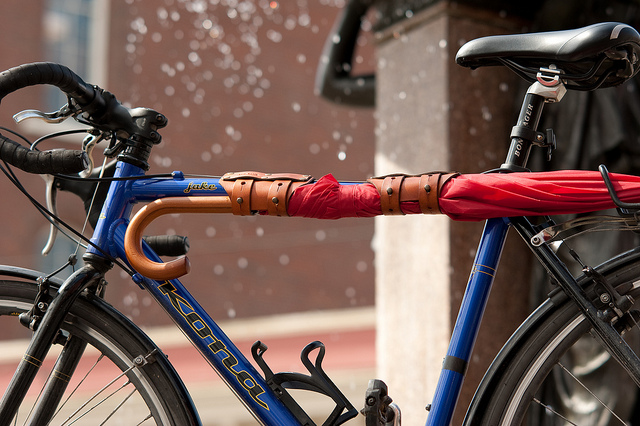Identify and read out the text in this image. JUKE kona AGER BON 